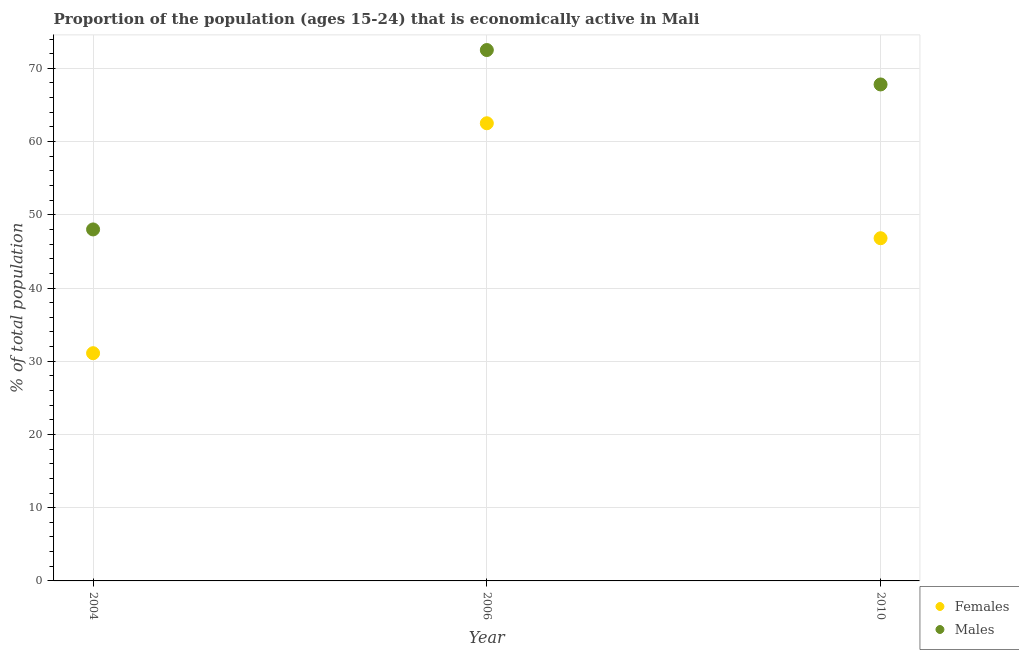How many different coloured dotlines are there?
Offer a terse response. 2. Is the number of dotlines equal to the number of legend labels?
Your answer should be very brief. Yes. What is the percentage of economically active female population in 2004?
Make the answer very short. 31.1. Across all years, what is the maximum percentage of economically active male population?
Make the answer very short. 72.5. Across all years, what is the minimum percentage of economically active female population?
Give a very brief answer. 31.1. In which year was the percentage of economically active male population maximum?
Provide a short and direct response. 2006. In which year was the percentage of economically active female population minimum?
Ensure brevity in your answer.  2004. What is the total percentage of economically active female population in the graph?
Keep it short and to the point. 140.4. What is the difference between the percentage of economically active female population in 2004 and that in 2010?
Offer a terse response. -15.7. What is the difference between the percentage of economically active female population in 2010 and the percentage of economically active male population in 2004?
Your answer should be very brief. -1.2. What is the average percentage of economically active female population per year?
Provide a short and direct response. 46.8. What is the ratio of the percentage of economically active male population in 2004 to that in 2006?
Give a very brief answer. 0.66. Is the difference between the percentage of economically active male population in 2004 and 2006 greater than the difference between the percentage of economically active female population in 2004 and 2006?
Your answer should be very brief. Yes. What is the difference between the highest and the second highest percentage of economically active male population?
Offer a terse response. 4.7. What is the difference between the highest and the lowest percentage of economically active female population?
Provide a short and direct response. 31.4. In how many years, is the percentage of economically active female population greater than the average percentage of economically active female population taken over all years?
Make the answer very short. 1. Is the sum of the percentage of economically active female population in 2006 and 2010 greater than the maximum percentage of economically active male population across all years?
Keep it short and to the point. Yes. Does the percentage of economically active male population monotonically increase over the years?
Keep it short and to the point. No. Is the percentage of economically active female population strictly greater than the percentage of economically active male population over the years?
Ensure brevity in your answer.  No. How many years are there in the graph?
Ensure brevity in your answer.  3. Are the values on the major ticks of Y-axis written in scientific E-notation?
Ensure brevity in your answer.  No. Does the graph contain any zero values?
Offer a very short reply. No. What is the title of the graph?
Provide a succinct answer. Proportion of the population (ages 15-24) that is economically active in Mali. What is the label or title of the X-axis?
Give a very brief answer. Year. What is the label or title of the Y-axis?
Ensure brevity in your answer.  % of total population. What is the % of total population in Females in 2004?
Your answer should be compact. 31.1. What is the % of total population in Females in 2006?
Ensure brevity in your answer.  62.5. What is the % of total population in Males in 2006?
Offer a very short reply. 72.5. What is the % of total population of Females in 2010?
Keep it short and to the point. 46.8. What is the % of total population in Males in 2010?
Your response must be concise. 67.8. Across all years, what is the maximum % of total population in Females?
Provide a succinct answer. 62.5. Across all years, what is the maximum % of total population in Males?
Provide a short and direct response. 72.5. Across all years, what is the minimum % of total population in Females?
Provide a short and direct response. 31.1. Across all years, what is the minimum % of total population of Males?
Give a very brief answer. 48. What is the total % of total population of Females in the graph?
Your answer should be compact. 140.4. What is the total % of total population in Males in the graph?
Your answer should be very brief. 188.3. What is the difference between the % of total population in Females in 2004 and that in 2006?
Ensure brevity in your answer.  -31.4. What is the difference between the % of total population in Males in 2004 and that in 2006?
Your response must be concise. -24.5. What is the difference between the % of total population in Females in 2004 and that in 2010?
Your response must be concise. -15.7. What is the difference between the % of total population in Males in 2004 and that in 2010?
Give a very brief answer. -19.8. What is the difference between the % of total population of Females in 2004 and the % of total population of Males in 2006?
Your response must be concise. -41.4. What is the difference between the % of total population in Females in 2004 and the % of total population in Males in 2010?
Your answer should be very brief. -36.7. What is the average % of total population of Females per year?
Keep it short and to the point. 46.8. What is the average % of total population of Males per year?
Give a very brief answer. 62.77. In the year 2004, what is the difference between the % of total population in Females and % of total population in Males?
Your answer should be very brief. -16.9. In the year 2006, what is the difference between the % of total population of Females and % of total population of Males?
Your response must be concise. -10. In the year 2010, what is the difference between the % of total population in Females and % of total population in Males?
Your response must be concise. -21. What is the ratio of the % of total population of Females in 2004 to that in 2006?
Your answer should be compact. 0.5. What is the ratio of the % of total population in Males in 2004 to that in 2006?
Your answer should be compact. 0.66. What is the ratio of the % of total population in Females in 2004 to that in 2010?
Provide a short and direct response. 0.66. What is the ratio of the % of total population in Males in 2004 to that in 2010?
Ensure brevity in your answer.  0.71. What is the ratio of the % of total population in Females in 2006 to that in 2010?
Your answer should be compact. 1.34. What is the ratio of the % of total population of Males in 2006 to that in 2010?
Offer a very short reply. 1.07. What is the difference between the highest and the second highest % of total population of Males?
Offer a very short reply. 4.7. What is the difference between the highest and the lowest % of total population in Females?
Provide a succinct answer. 31.4. What is the difference between the highest and the lowest % of total population in Males?
Ensure brevity in your answer.  24.5. 